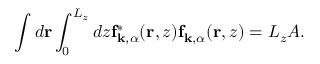Convert formula to latex. <formula><loc_0><loc_0><loc_500><loc_500>\int d r \int _ { 0 } ^ { L _ { z } } d z f _ { k , \alpha } ^ { * } ( r , z ) f _ { k , \alpha } ( r , z ) = L _ { z } A .</formula> 